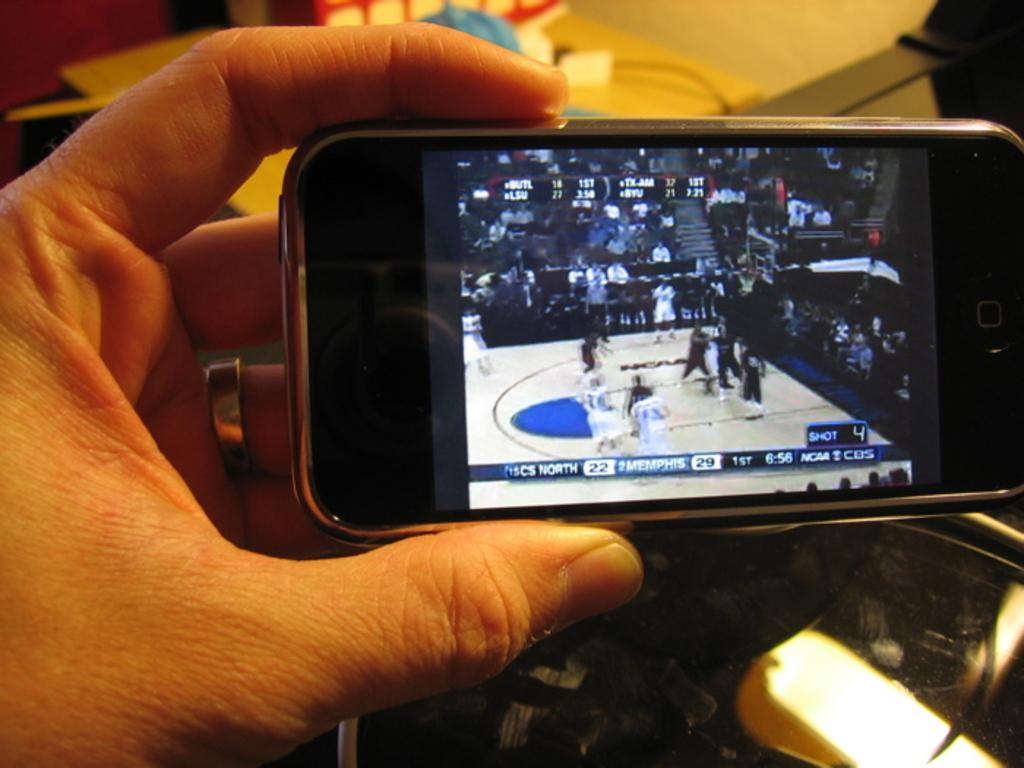<image>
Present a compact description of the photo's key features. A phone screen displays a basketball game between Memphis and CS North. 